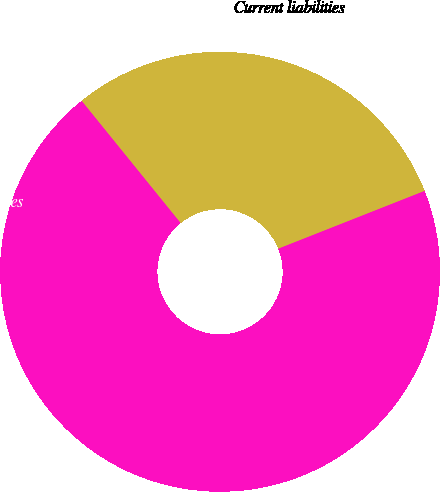<chart> <loc_0><loc_0><loc_500><loc_500><pie_chart><fcel>Current liabilities<fcel>Noncurrent liabilities<fcel>Total<nl><fcel>29.85%<fcel>20.15%<fcel>50.0%<nl></chart> 